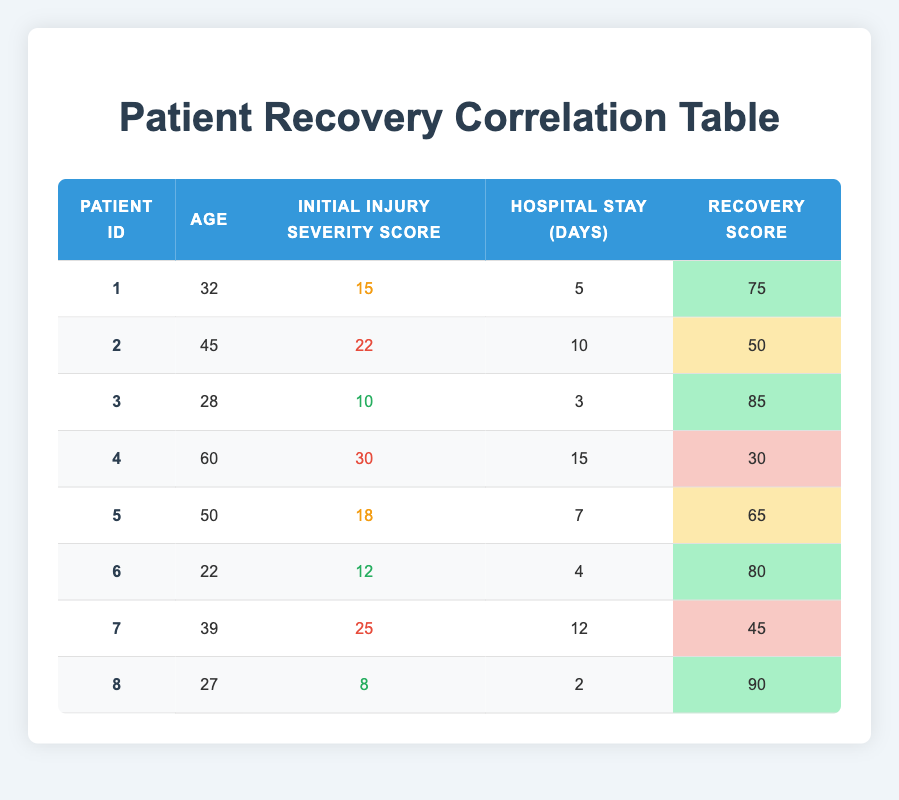What is the highest recovery score in the table? The recovery scores listed in the table are 75, 50, 85, 30, 65, 80, 45, and 90. The highest among these is 90.
Answer: 90 What is the initial injury severity score for patient 4? Patient 4's initial injury severity score is explicitly stated in the table as 30.
Answer: 30 What is the average hospital stay for patients who have a recovery score above 70? The relevant patients with recovery scores above 70 are patient 1 (5 days), patient 3 (3 days), patient 6 (4 days), and patient 8 (2 days). Their total hospital stay is 5 + 3 + 4 + 2 = 14 days. Since there are 4 patients, the average is 14/4 = 3.5 days.
Answer: 3.5 days Did any patient with a severity score of 25 or higher have a recovery score above 50? Patients with severity scores of 25 or higher include patient 2 (22), patient 4 (30), and patient 7 (25). Their recovery scores are 50, 30, and 45, respectively, none of which exceed 50, so the answer is no.
Answer: No How many days did patient 3 stay in the hospital, and how does it compare to the average stay of all patients? Patient 3 stayed 3 days in the hospital. The total hospital stay for all patients is 5 + 10 + 3 + 15 + 7 + 4 + 12 + 2 = 68 days with 8 patients, yielding an average of 68/8 = 8.5 days. Comparing 3 days to the average: 3 is below 8.5 days.
Answer: 3 days, below average What was the initial injury severity score for the youngest patient in the group? The youngest patient is patient 6, who is 22 years old. Their initial injury severity score is stated in the table as 12.
Answer: 12 